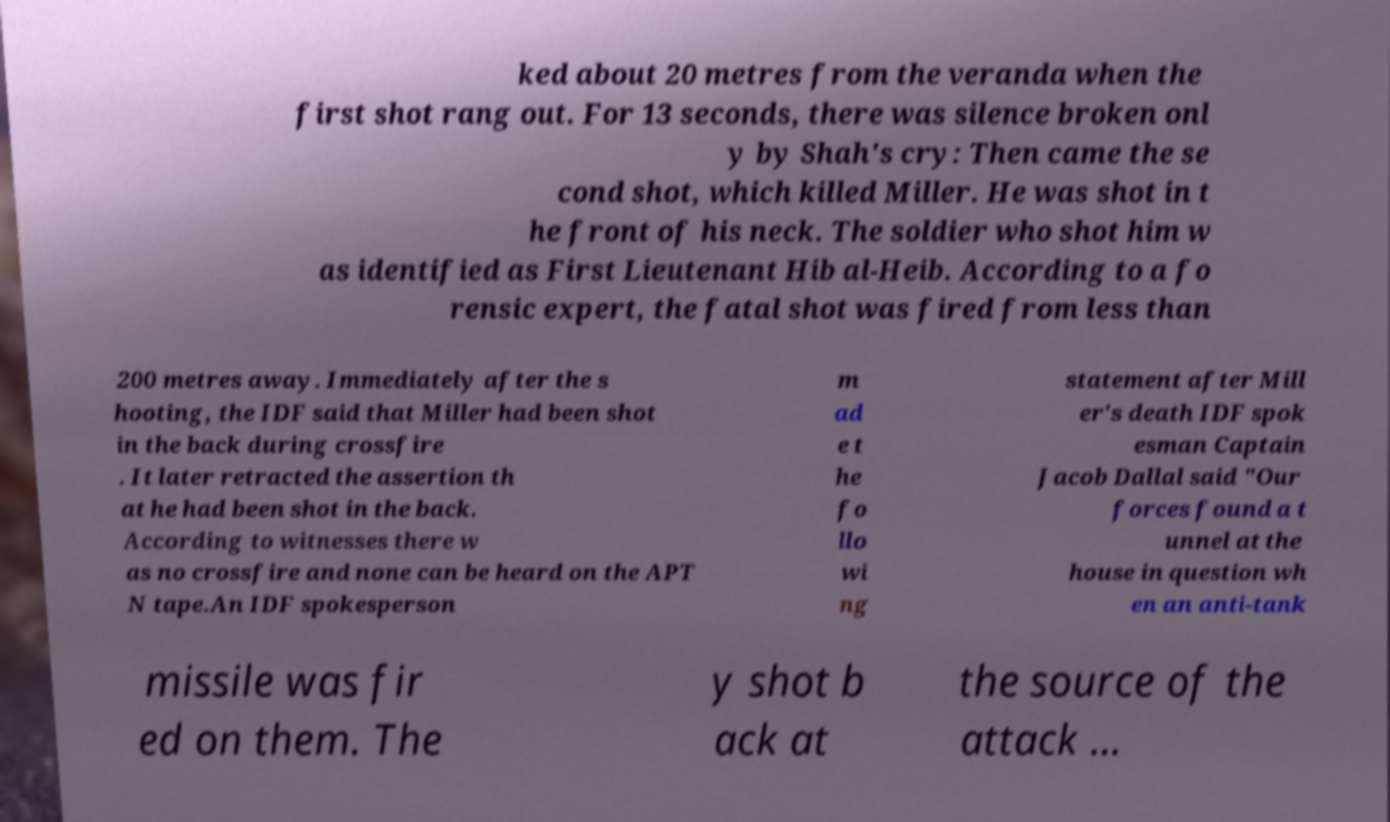What messages or text are displayed in this image? I need them in a readable, typed format. ked about 20 metres from the veranda when the first shot rang out. For 13 seconds, there was silence broken onl y by Shah's cry: Then came the se cond shot, which killed Miller. He was shot in t he front of his neck. The soldier who shot him w as identified as First Lieutenant Hib al-Heib. According to a fo rensic expert, the fatal shot was fired from less than 200 metres away. Immediately after the s hooting, the IDF said that Miller had been shot in the back during crossfire . It later retracted the assertion th at he had been shot in the back. According to witnesses there w as no crossfire and none can be heard on the APT N tape.An IDF spokesperson m ad e t he fo llo wi ng statement after Mill er's death IDF spok esman Captain Jacob Dallal said "Our forces found a t unnel at the house in question wh en an anti-tank missile was fir ed on them. The y shot b ack at the source of the attack ... 